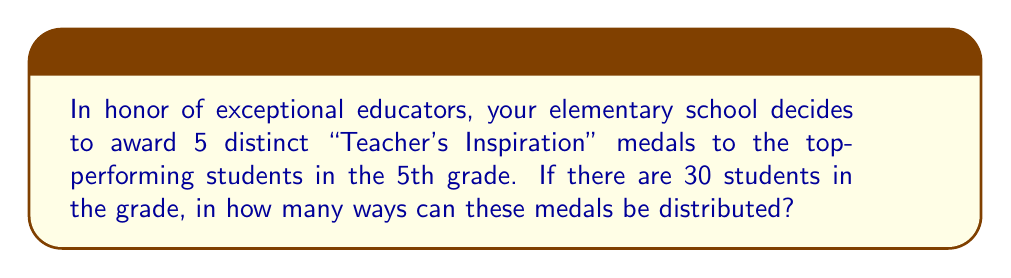Could you help me with this problem? Let's approach this step-by-step:

1) We are selecting 5 students out of 30 to receive the medals.

2) The order of selection matters because each medal is distinct. This means we are dealing with a permutation, not a combination.

3) We can think of this as filling 5 positions (one for each medal) with 30 choices for the first position, 29 for the second, and so on.

4) This scenario is represented by the permutation formula:

   $$P(n,r) = \frac{n!}{(n-r)!}$$

   Where $n$ is the total number of items to choose from, and $r$ is the number of items being chosen.

5) In this case, $n = 30$ (total students) and $r = 5$ (medals to distribute).

6) Plugging these values into our formula:

   $$P(30,5) = \frac{30!}{(30-5)!} = \frac{30!}{25!}$$

7) Expanding this:

   $$\frac{30 \times 29 \times 28 \times 27 \times 26 \times 25!}{25!}$$

8) The 25! cancels out in the numerator and denominator:

   $$30 \times 29 \times 28 \times 27 \times 26 = 17,100,720$$

Therefore, there are 17,100,720 ways to distribute the medals.
Answer: 17,100,720 